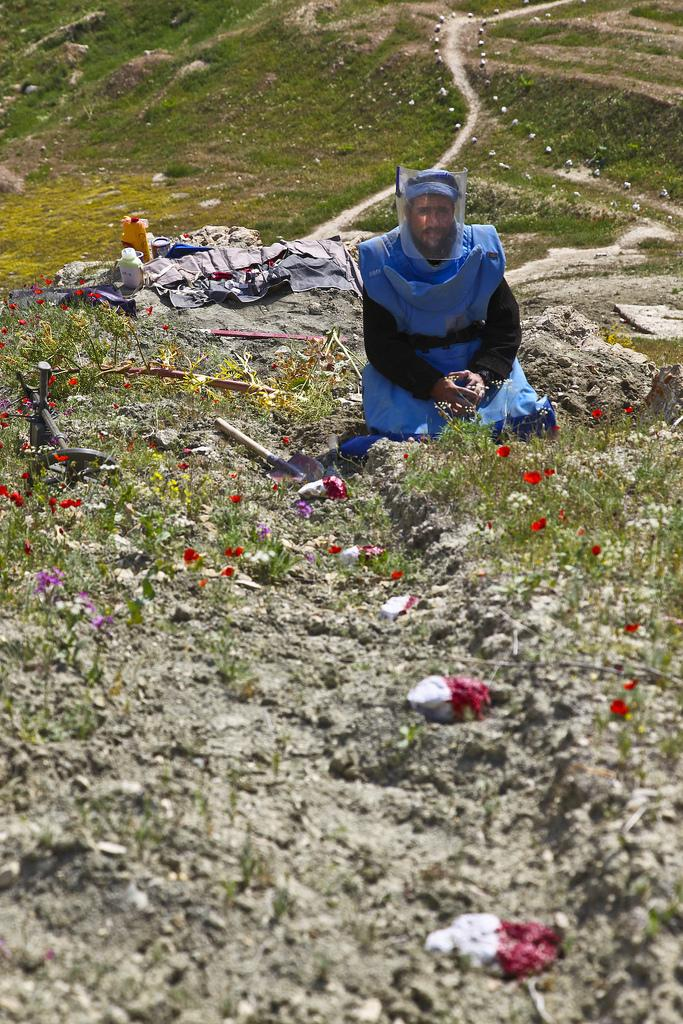Who or what is the main subject in the image? There is a person in the image. What is the person wearing? The person is wearing a blue dress. Where is the person sitting? The person is sitting on a rock. What can be seen behind the person? There are other objects behind the person. What type of flowers are in front of the person? There are red flowers in front of the person. What class is the person attending in the image? There is no indication of a class or any educational setting in the image. 